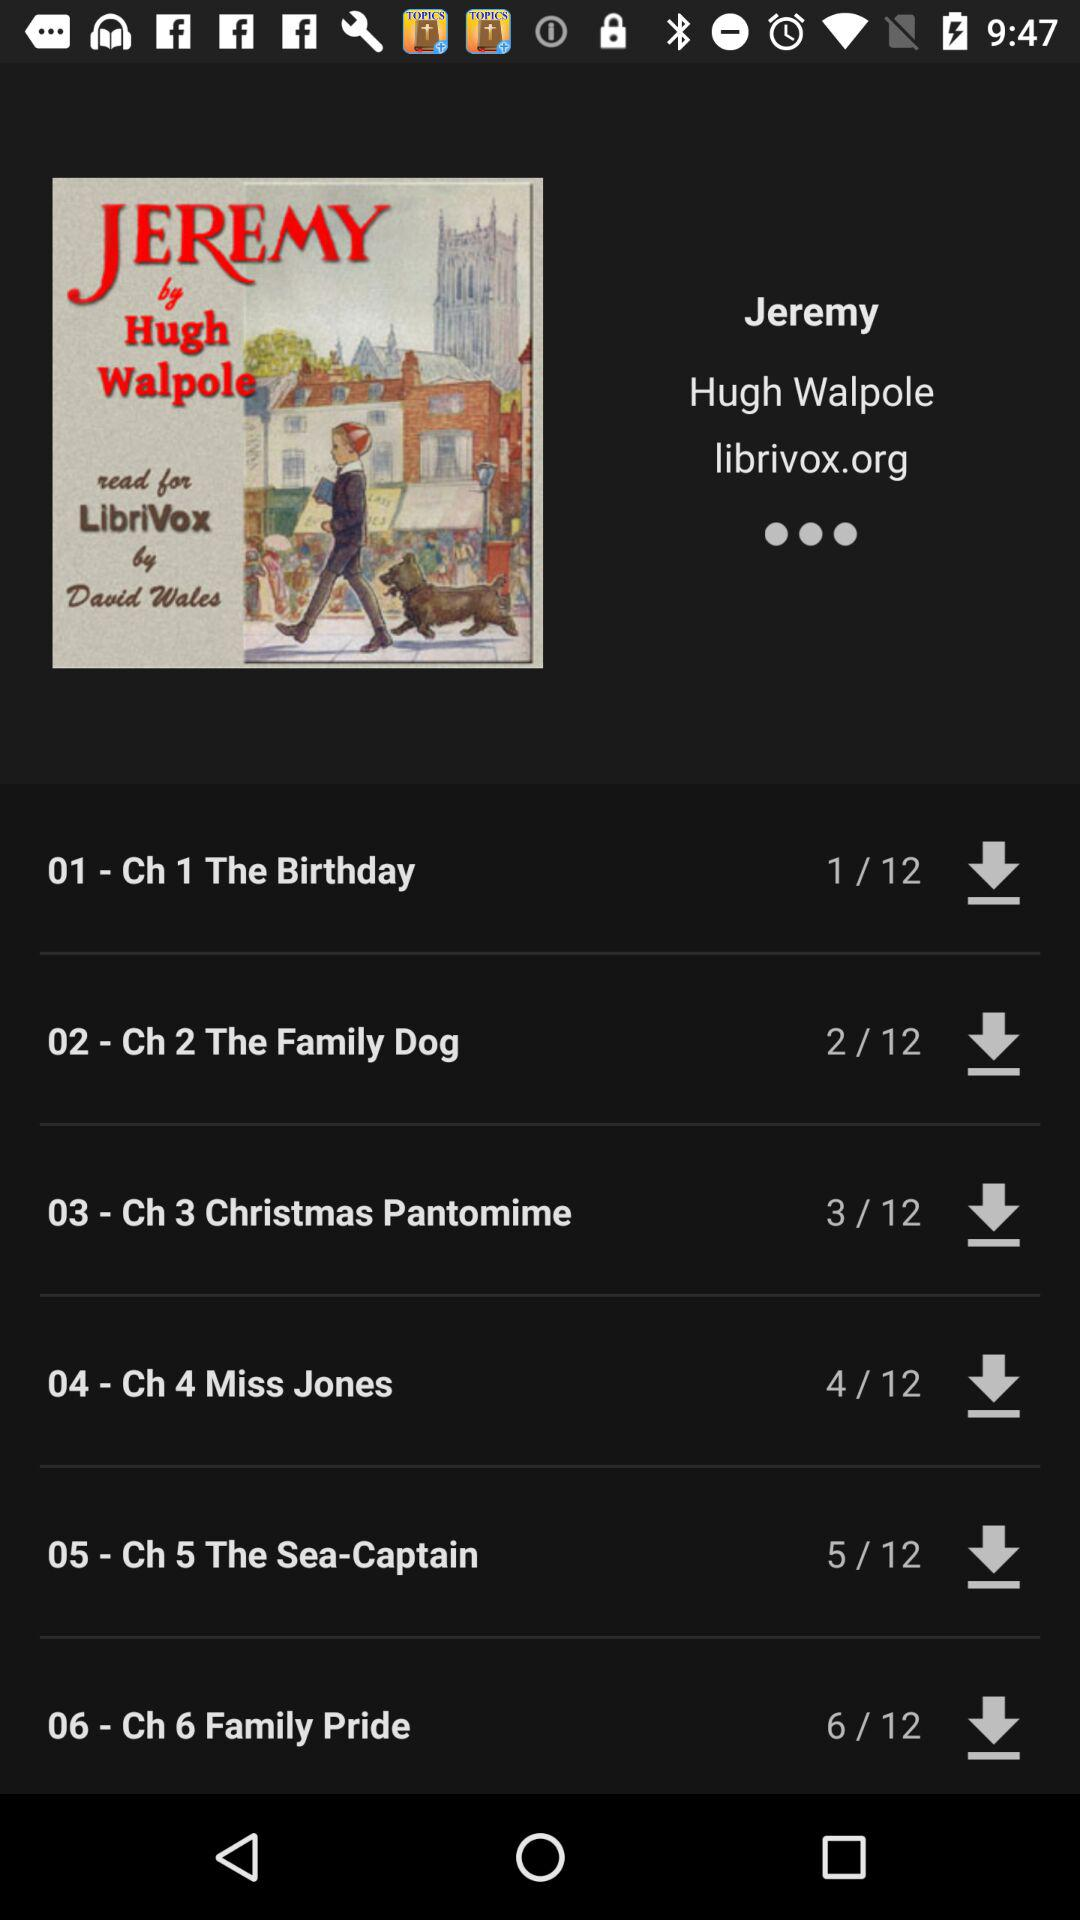What is the name of Chapter 5?
Answer the question using a single word or phrase. The chapter name is "The Sea-Captain." 